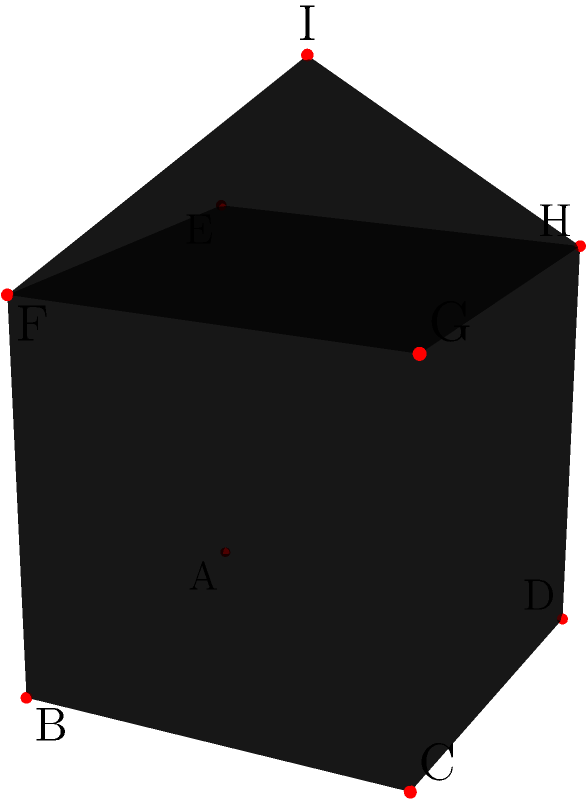Consider the complex polyhedron shown in the figure, which consists of a cube ABCDEFGH with side length 2 units and a pyramid EFGHI with apex I directly above the center of the top face of the cube. The height of the pyramid is 1 unit. Calculate the total surface area of this polyhedron. How does this 3D representation challenge the limitations of 2D illustrations typically found in traditional books? To calculate the total surface area, we need to consider all visible faces of the polyhedron:

1) The bottom face of the cube: $A_{bottom} = 2^2 = 4$ square units

2) The four vertical faces of the cube:
   $A_{vertical} = 4 \cdot (2 \cdot 2) = 16$ square units

3) The four triangular faces of the pyramid:
   First, we need to find the length of the edge of the pyramid base to its apex.
   Using the Pythagorean theorem:
   $l^2 = 1^2 + (\sqrt{2})^2 = 1 + 2 = 3$
   $l = \sqrt{3}$

   Area of one triangular face: $A_{triangle} = \frac{1}{2} \cdot 2 \cdot \sqrt{3} = \sqrt{3}$
   Total area of four triangular faces: $A_{pyramidfaces} = 4\sqrt{3}$ square units

Total surface area: $A_{total} = A_{bottom} + A_{vertical} + A_{pyramidfaces}$
$A_{total} = 4 + 16 + 4\sqrt{3} = 20 + 4\sqrt{3}$ square units

This 3D representation challenges the limitations of 2D illustrations in books by:
1) Providing a clear view of all faces and edges, which might be ambiguous in a 2D drawing.
2) Allowing for rotation and different perspectives, which is impossible in a static 2D image.
3) Showing depth and spatial relationships more accurately, especially for complex shapes.
4) Enabling better understanding of how different parts of the polyhedron connect and intersect.
Answer: $20 + 4\sqrt{3}$ square units 